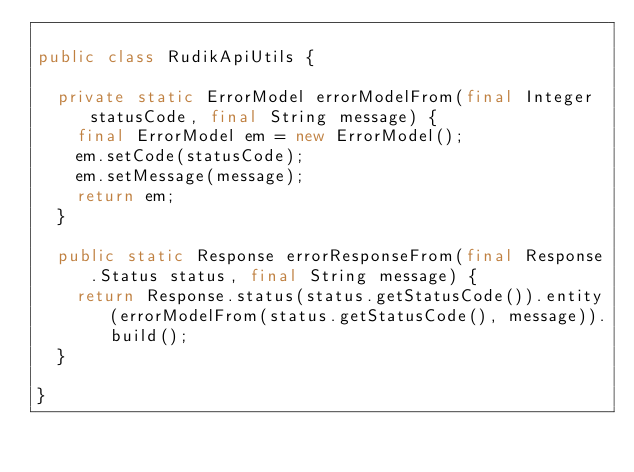Convert code to text. <code><loc_0><loc_0><loc_500><loc_500><_Java_>
public class RudikApiUtils {

  private static ErrorModel errorModelFrom(final Integer statusCode, final String message) {
    final ErrorModel em = new ErrorModel();
    em.setCode(statusCode);
    em.setMessage(message);
    return em;
  }

  public static Response errorResponseFrom(final Response.Status status, final String message) {
    return Response.status(status.getStatusCode()).entity(errorModelFrom(status.getStatusCode(), message)).build();
  }

}
</code> 